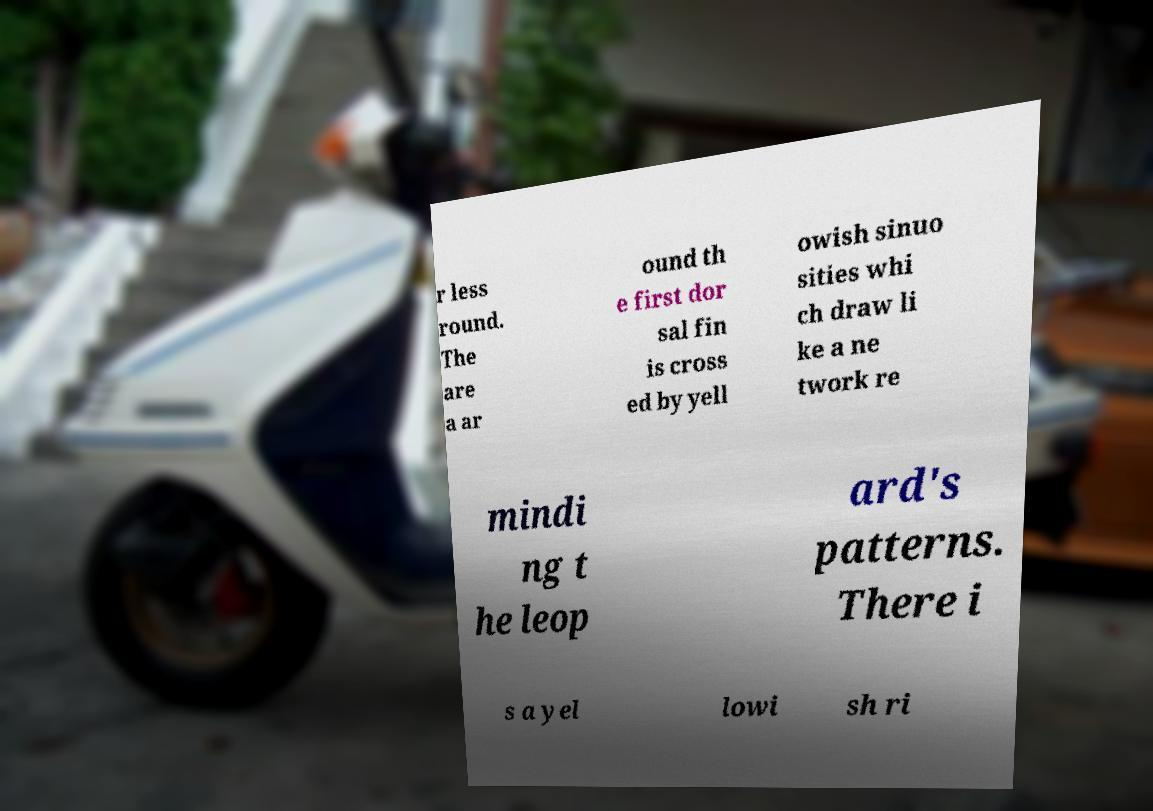Can you read and provide the text displayed in the image?This photo seems to have some interesting text. Can you extract and type it out for me? r less round. The are a ar ound th e first dor sal fin is cross ed by yell owish sinuo sities whi ch draw li ke a ne twork re mindi ng t he leop ard's patterns. There i s a yel lowi sh ri 